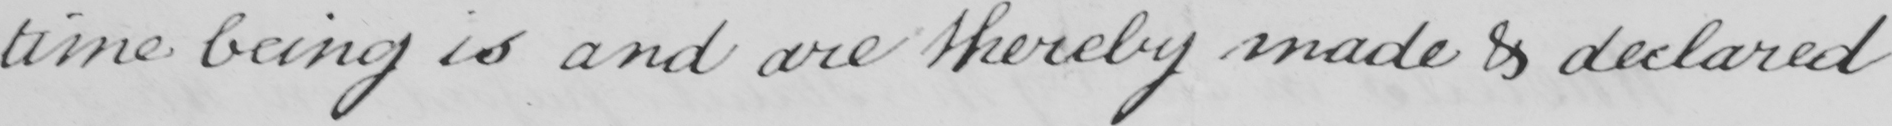Can you tell me what this handwritten text says? time being is and are thereby made & declared 